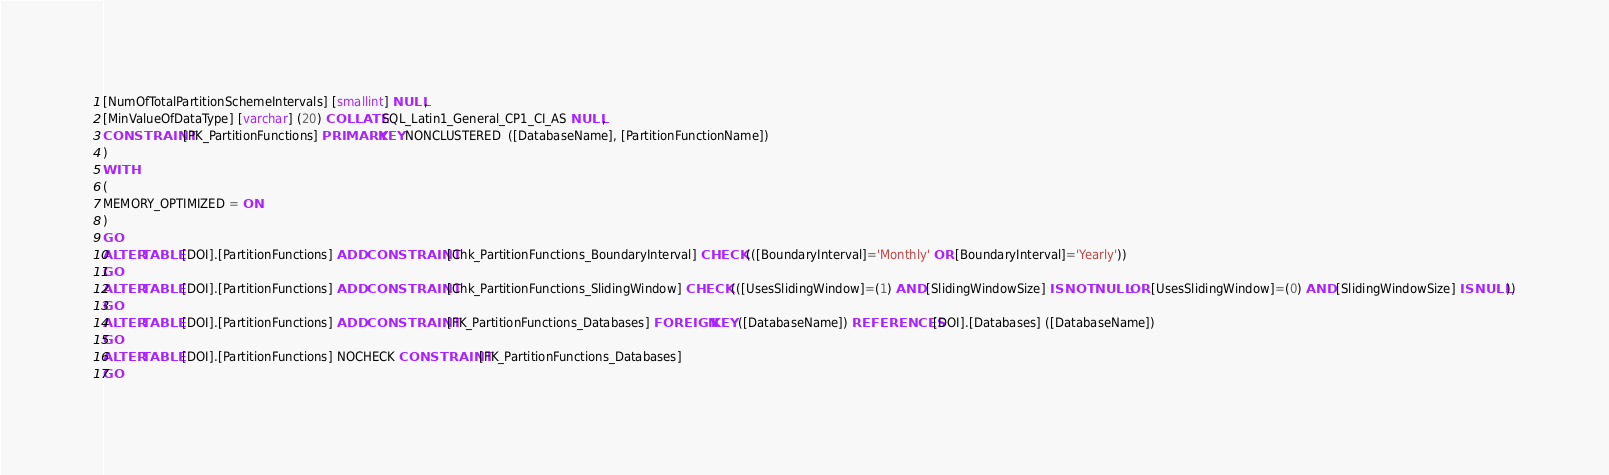Convert code to text. <code><loc_0><loc_0><loc_500><loc_500><_SQL_>[NumOfTotalPartitionSchemeIntervals] [smallint] NULL,
[MinValueOfDataType] [varchar] (20) COLLATE SQL_Latin1_General_CP1_CI_AS NULL,
CONSTRAINT [PK_PartitionFunctions] PRIMARY KEY NONCLUSTERED  ([DatabaseName], [PartitionFunctionName])
)
WITH
(
MEMORY_OPTIMIZED = ON
)
GO
ALTER TABLE [DOI].[PartitionFunctions] ADD CONSTRAINT [Chk_PartitionFunctions_BoundaryInterval] CHECK (([BoundaryInterval]='Monthly' OR [BoundaryInterval]='Yearly'))
GO
ALTER TABLE [DOI].[PartitionFunctions] ADD CONSTRAINT [Chk_PartitionFunctions_SlidingWindow] CHECK (([UsesSlidingWindow]=(1) AND [SlidingWindowSize] IS NOT NULL OR [UsesSlidingWindow]=(0) AND [SlidingWindowSize] IS NULL))
GO
ALTER TABLE [DOI].[PartitionFunctions] ADD CONSTRAINT [FK_PartitionFunctions_Databases] FOREIGN KEY ([DatabaseName]) REFERENCES [DOI].[Databases] ([DatabaseName])
GO
ALTER TABLE [DOI].[PartitionFunctions] NOCHECK CONSTRAINT [FK_PartitionFunctions_Databases]
GO
</code> 